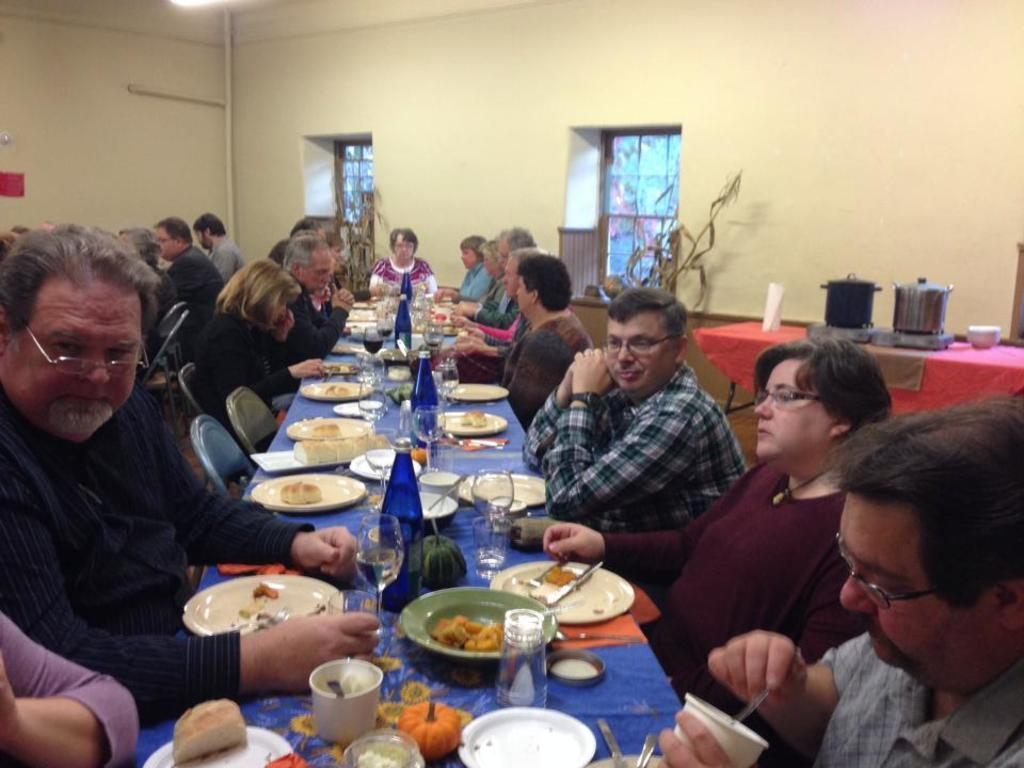What are the people in the image doing? The persons in the image are sitting on chairs. What objects are on the table in the image? There are plates and bottles on the table in the image. What can be seen in the background of the image? There is a wall in the background of the image. Can you point out the map on the table in the image? There is no map present on the table in the image. What type of pipe can be seen connecting the bottles in the image? There is no pipe connecting the bottles in the image. 